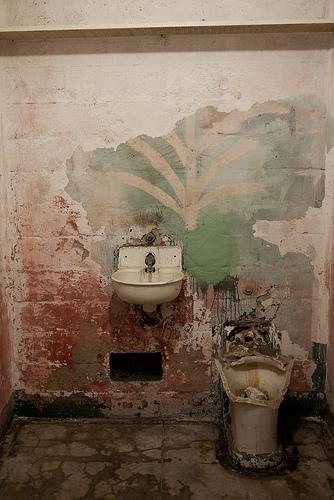Is this toilet functional?
Answer briefly. No. Is there a matchbox in the image?
Write a very short answer. No. Where is the hole located?
Write a very short answer. Wall. What is all over the stone in this picture?
Concise answer only. Paint. Is the room in the picture clean or dirty?
Answer briefly. Dirty. Is the wall rusted?
Keep it brief. Yes. What is on the wall behind the toilet?
Give a very brief answer. Paint. What material is the wall behind the artwork made from?
Quick response, please. Concrete. 